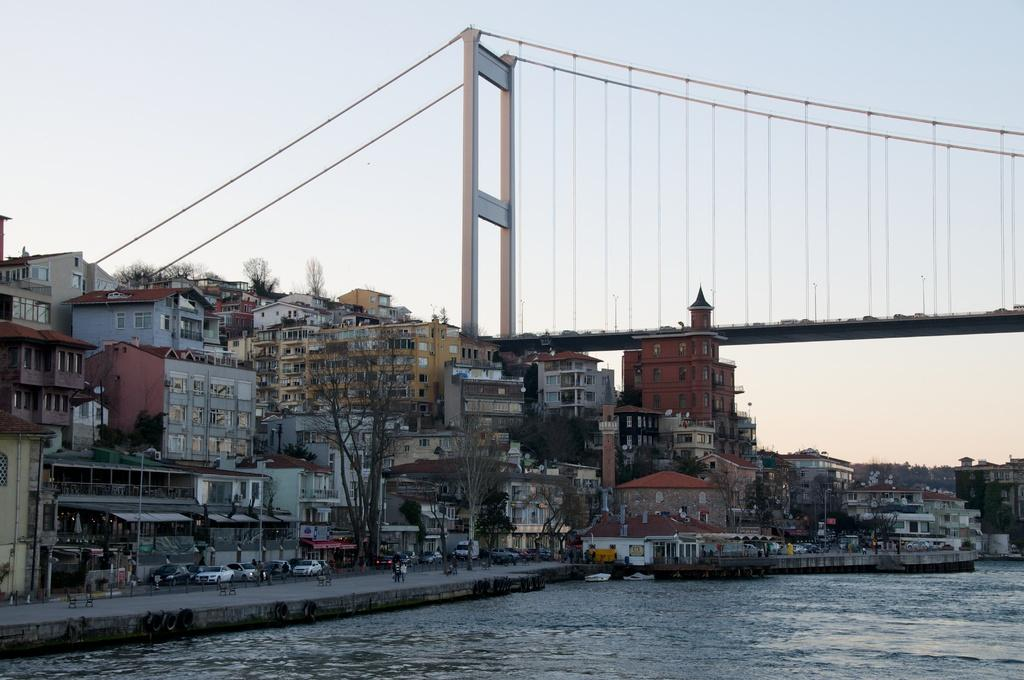What type of natural feature is present in the image? There is a river in the image. What is located near the river? There is a road beside the river. What type of man-made structures can be seen in the image? There are buildings in the image. What connects the two sides of the river in the image? There is a bridge visible at the top of the image. What can be seen in the background of the image? The sky is visible in the background of the image. What type of crime is being committed by the daughter in the image? There is no mention of a daughter or any crime in the image; it features a river, road, buildings, a bridge, and the sky. 